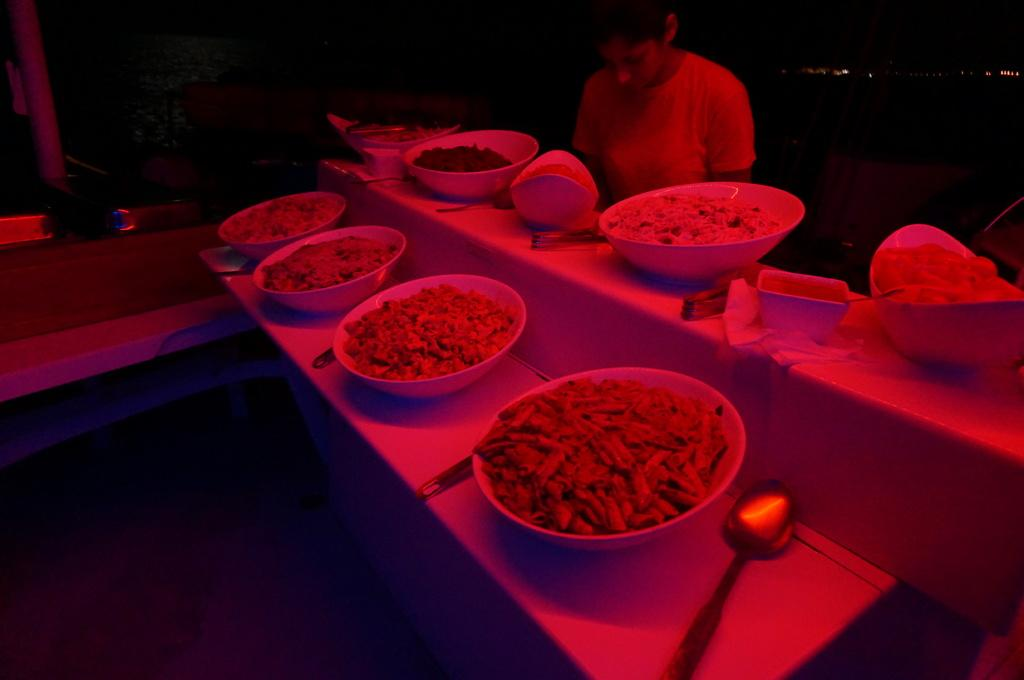What is the main subject in the image? There is a person standing in the image. What can be seen on the tables in the image? There are bowls, food, and spoons on the tables in the image. What is the color of the background in the image? The background of the image is dark. What is the price of the road in the image? There is no road present in the image, so it is not possible to determine its price. 